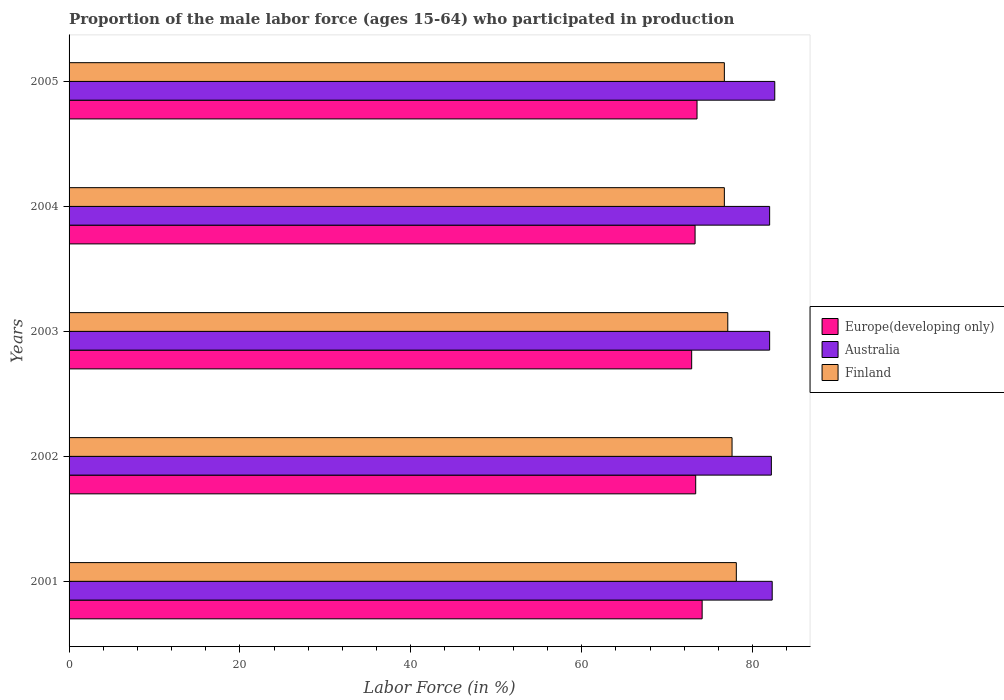How many different coloured bars are there?
Your answer should be very brief. 3. Are the number of bars on each tick of the Y-axis equal?
Provide a succinct answer. Yes. How many bars are there on the 2nd tick from the bottom?
Offer a very short reply. 3. What is the proportion of the male labor force who participated in production in Australia in 2005?
Your answer should be compact. 82.6. Across all years, what is the maximum proportion of the male labor force who participated in production in Finland?
Keep it short and to the point. 78.1. Across all years, what is the minimum proportion of the male labor force who participated in production in Finland?
Ensure brevity in your answer.  76.7. What is the total proportion of the male labor force who participated in production in Australia in the graph?
Offer a very short reply. 411.1. What is the difference between the proportion of the male labor force who participated in production in Finland in 2005 and the proportion of the male labor force who participated in production in Australia in 2001?
Ensure brevity in your answer.  -5.6. What is the average proportion of the male labor force who participated in production in Europe(developing only) per year?
Ensure brevity in your answer.  73.42. In the year 2005, what is the difference between the proportion of the male labor force who participated in production in Europe(developing only) and proportion of the male labor force who participated in production in Australia?
Your response must be concise. -9.1. What is the ratio of the proportion of the male labor force who participated in production in Europe(developing only) in 2001 to that in 2003?
Your answer should be compact. 1.02. Is the difference between the proportion of the male labor force who participated in production in Europe(developing only) in 2001 and 2003 greater than the difference between the proportion of the male labor force who participated in production in Australia in 2001 and 2003?
Make the answer very short. Yes. What is the difference between the highest and the second highest proportion of the male labor force who participated in production in Finland?
Provide a succinct answer. 0.5. What is the difference between the highest and the lowest proportion of the male labor force who participated in production in Australia?
Offer a very short reply. 0.6. What does the 3rd bar from the top in 2003 represents?
Keep it short and to the point. Europe(developing only). What does the 1st bar from the bottom in 2001 represents?
Make the answer very short. Europe(developing only). Is it the case that in every year, the sum of the proportion of the male labor force who participated in production in Europe(developing only) and proportion of the male labor force who participated in production in Finland is greater than the proportion of the male labor force who participated in production in Australia?
Ensure brevity in your answer.  Yes. How many bars are there?
Keep it short and to the point. 15. Are all the bars in the graph horizontal?
Offer a very short reply. Yes. What is the difference between two consecutive major ticks on the X-axis?
Give a very brief answer. 20. Does the graph contain any zero values?
Your answer should be very brief. No. Does the graph contain grids?
Your answer should be compact. No. Where does the legend appear in the graph?
Make the answer very short. Center right. How are the legend labels stacked?
Your answer should be very brief. Vertical. What is the title of the graph?
Your answer should be compact. Proportion of the male labor force (ages 15-64) who participated in production. What is the label or title of the X-axis?
Ensure brevity in your answer.  Labor Force (in %). What is the Labor Force (in %) in Europe(developing only) in 2001?
Provide a succinct answer. 74.1. What is the Labor Force (in %) of Australia in 2001?
Offer a terse response. 82.3. What is the Labor Force (in %) of Finland in 2001?
Your response must be concise. 78.1. What is the Labor Force (in %) of Europe(developing only) in 2002?
Provide a succinct answer. 73.34. What is the Labor Force (in %) of Australia in 2002?
Your answer should be compact. 82.2. What is the Labor Force (in %) in Finland in 2002?
Your answer should be compact. 77.6. What is the Labor Force (in %) of Europe(developing only) in 2003?
Give a very brief answer. 72.87. What is the Labor Force (in %) of Australia in 2003?
Make the answer very short. 82. What is the Labor Force (in %) of Finland in 2003?
Your answer should be very brief. 77.1. What is the Labor Force (in %) in Europe(developing only) in 2004?
Make the answer very short. 73.27. What is the Labor Force (in %) in Australia in 2004?
Your response must be concise. 82. What is the Labor Force (in %) in Finland in 2004?
Give a very brief answer. 76.7. What is the Labor Force (in %) in Europe(developing only) in 2005?
Provide a short and direct response. 73.5. What is the Labor Force (in %) in Australia in 2005?
Offer a very short reply. 82.6. What is the Labor Force (in %) of Finland in 2005?
Your answer should be very brief. 76.7. Across all years, what is the maximum Labor Force (in %) of Europe(developing only)?
Your response must be concise. 74.1. Across all years, what is the maximum Labor Force (in %) of Australia?
Give a very brief answer. 82.6. Across all years, what is the maximum Labor Force (in %) of Finland?
Offer a very short reply. 78.1. Across all years, what is the minimum Labor Force (in %) of Europe(developing only)?
Provide a succinct answer. 72.87. Across all years, what is the minimum Labor Force (in %) of Finland?
Provide a succinct answer. 76.7. What is the total Labor Force (in %) in Europe(developing only) in the graph?
Offer a terse response. 367.09. What is the total Labor Force (in %) in Australia in the graph?
Give a very brief answer. 411.1. What is the total Labor Force (in %) in Finland in the graph?
Your response must be concise. 386.2. What is the difference between the Labor Force (in %) of Europe(developing only) in 2001 and that in 2002?
Provide a short and direct response. 0.75. What is the difference between the Labor Force (in %) of Finland in 2001 and that in 2002?
Ensure brevity in your answer.  0.5. What is the difference between the Labor Force (in %) of Europe(developing only) in 2001 and that in 2003?
Provide a short and direct response. 1.23. What is the difference between the Labor Force (in %) of Finland in 2001 and that in 2003?
Offer a terse response. 1. What is the difference between the Labor Force (in %) in Europe(developing only) in 2001 and that in 2004?
Give a very brief answer. 0.83. What is the difference between the Labor Force (in %) in Finland in 2001 and that in 2004?
Ensure brevity in your answer.  1.4. What is the difference between the Labor Force (in %) of Europe(developing only) in 2001 and that in 2005?
Make the answer very short. 0.6. What is the difference between the Labor Force (in %) of Europe(developing only) in 2002 and that in 2003?
Offer a terse response. 0.47. What is the difference between the Labor Force (in %) of Finland in 2002 and that in 2003?
Your answer should be very brief. 0.5. What is the difference between the Labor Force (in %) in Europe(developing only) in 2002 and that in 2004?
Offer a very short reply. 0.07. What is the difference between the Labor Force (in %) in Australia in 2002 and that in 2004?
Ensure brevity in your answer.  0.2. What is the difference between the Labor Force (in %) in Europe(developing only) in 2002 and that in 2005?
Your response must be concise. -0.16. What is the difference between the Labor Force (in %) in Australia in 2002 and that in 2005?
Offer a very short reply. -0.4. What is the difference between the Labor Force (in %) of Europe(developing only) in 2003 and that in 2004?
Make the answer very short. -0.4. What is the difference between the Labor Force (in %) of Europe(developing only) in 2003 and that in 2005?
Ensure brevity in your answer.  -0.63. What is the difference between the Labor Force (in %) in Australia in 2003 and that in 2005?
Keep it short and to the point. -0.6. What is the difference between the Labor Force (in %) in Finland in 2003 and that in 2005?
Provide a short and direct response. 0.4. What is the difference between the Labor Force (in %) of Europe(developing only) in 2004 and that in 2005?
Give a very brief answer. -0.23. What is the difference between the Labor Force (in %) of Finland in 2004 and that in 2005?
Provide a short and direct response. 0. What is the difference between the Labor Force (in %) in Europe(developing only) in 2001 and the Labor Force (in %) in Australia in 2002?
Keep it short and to the point. -8.1. What is the difference between the Labor Force (in %) in Europe(developing only) in 2001 and the Labor Force (in %) in Finland in 2002?
Offer a very short reply. -3.5. What is the difference between the Labor Force (in %) in Europe(developing only) in 2001 and the Labor Force (in %) in Australia in 2003?
Make the answer very short. -7.9. What is the difference between the Labor Force (in %) of Europe(developing only) in 2001 and the Labor Force (in %) of Finland in 2003?
Provide a short and direct response. -3. What is the difference between the Labor Force (in %) in Europe(developing only) in 2001 and the Labor Force (in %) in Australia in 2004?
Keep it short and to the point. -7.9. What is the difference between the Labor Force (in %) in Europe(developing only) in 2001 and the Labor Force (in %) in Finland in 2004?
Make the answer very short. -2.6. What is the difference between the Labor Force (in %) in Europe(developing only) in 2001 and the Labor Force (in %) in Australia in 2005?
Make the answer very short. -8.5. What is the difference between the Labor Force (in %) in Europe(developing only) in 2001 and the Labor Force (in %) in Finland in 2005?
Your answer should be compact. -2.6. What is the difference between the Labor Force (in %) in Europe(developing only) in 2002 and the Labor Force (in %) in Australia in 2003?
Offer a terse response. -8.66. What is the difference between the Labor Force (in %) of Europe(developing only) in 2002 and the Labor Force (in %) of Finland in 2003?
Your answer should be compact. -3.76. What is the difference between the Labor Force (in %) of Europe(developing only) in 2002 and the Labor Force (in %) of Australia in 2004?
Offer a terse response. -8.66. What is the difference between the Labor Force (in %) of Europe(developing only) in 2002 and the Labor Force (in %) of Finland in 2004?
Your response must be concise. -3.36. What is the difference between the Labor Force (in %) of Australia in 2002 and the Labor Force (in %) of Finland in 2004?
Keep it short and to the point. 5.5. What is the difference between the Labor Force (in %) of Europe(developing only) in 2002 and the Labor Force (in %) of Australia in 2005?
Keep it short and to the point. -9.26. What is the difference between the Labor Force (in %) in Europe(developing only) in 2002 and the Labor Force (in %) in Finland in 2005?
Offer a terse response. -3.36. What is the difference between the Labor Force (in %) in Australia in 2002 and the Labor Force (in %) in Finland in 2005?
Offer a very short reply. 5.5. What is the difference between the Labor Force (in %) of Europe(developing only) in 2003 and the Labor Force (in %) of Australia in 2004?
Ensure brevity in your answer.  -9.13. What is the difference between the Labor Force (in %) of Europe(developing only) in 2003 and the Labor Force (in %) of Finland in 2004?
Ensure brevity in your answer.  -3.83. What is the difference between the Labor Force (in %) in Europe(developing only) in 2003 and the Labor Force (in %) in Australia in 2005?
Offer a terse response. -9.73. What is the difference between the Labor Force (in %) of Europe(developing only) in 2003 and the Labor Force (in %) of Finland in 2005?
Your response must be concise. -3.83. What is the difference between the Labor Force (in %) in Australia in 2003 and the Labor Force (in %) in Finland in 2005?
Offer a very short reply. 5.3. What is the difference between the Labor Force (in %) of Europe(developing only) in 2004 and the Labor Force (in %) of Australia in 2005?
Ensure brevity in your answer.  -9.33. What is the difference between the Labor Force (in %) in Europe(developing only) in 2004 and the Labor Force (in %) in Finland in 2005?
Provide a short and direct response. -3.43. What is the difference between the Labor Force (in %) of Australia in 2004 and the Labor Force (in %) of Finland in 2005?
Provide a succinct answer. 5.3. What is the average Labor Force (in %) of Europe(developing only) per year?
Make the answer very short. 73.42. What is the average Labor Force (in %) in Australia per year?
Ensure brevity in your answer.  82.22. What is the average Labor Force (in %) in Finland per year?
Provide a short and direct response. 77.24. In the year 2001, what is the difference between the Labor Force (in %) of Europe(developing only) and Labor Force (in %) of Australia?
Provide a succinct answer. -8.2. In the year 2001, what is the difference between the Labor Force (in %) in Europe(developing only) and Labor Force (in %) in Finland?
Offer a very short reply. -4. In the year 2002, what is the difference between the Labor Force (in %) of Europe(developing only) and Labor Force (in %) of Australia?
Provide a succinct answer. -8.86. In the year 2002, what is the difference between the Labor Force (in %) of Europe(developing only) and Labor Force (in %) of Finland?
Make the answer very short. -4.26. In the year 2002, what is the difference between the Labor Force (in %) of Australia and Labor Force (in %) of Finland?
Offer a very short reply. 4.6. In the year 2003, what is the difference between the Labor Force (in %) of Europe(developing only) and Labor Force (in %) of Australia?
Offer a very short reply. -9.13. In the year 2003, what is the difference between the Labor Force (in %) of Europe(developing only) and Labor Force (in %) of Finland?
Give a very brief answer. -4.23. In the year 2004, what is the difference between the Labor Force (in %) of Europe(developing only) and Labor Force (in %) of Australia?
Provide a short and direct response. -8.73. In the year 2004, what is the difference between the Labor Force (in %) in Europe(developing only) and Labor Force (in %) in Finland?
Keep it short and to the point. -3.43. In the year 2005, what is the difference between the Labor Force (in %) of Europe(developing only) and Labor Force (in %) of Australia?
Your answer should be compact. -9.1. In the year 2005, what is the difference between the Labor Force (in %) in Europe(developing only) and Labor Force (in %) in Finland?
Your answer should be very brief. -3.2. What is the ratio of the Labor Force (in %) of Europe(developing only) in 2001 to that in 2002?
Ensure brevity in your answer.  1.01. What is the ratio of the Labor Force (in %) of Australia in 2001 to that in 2002?
Your answer should be compact. 1. What is the ratio of the Labor Force (in %) in Finland in 2001 to that in 2002?
Offer a very short reply. 1.01. What is the ratio of the Labor Force (in %) in Europe(developing only) in 2001 to that in 2003?
Offer a terse response. 1.02. What is the ratio of the Labor Force (in %) of Australia in 2001 to that in 2003?
Offer a very short reply. 1. What is the ratio of the Labor Force (in %) in Finland in 2001 to that in 2003?
Your response must be concise. 1.01. What is the ratio of the Labor Force (in %) in Europe(developing only) in 2001 to that in 2004?
Your answer should be compact. 1.01. What is the ratio of the Labor Force (in %) in Australia in 2001 to that in 2004?
Your answer should be very brief. 1. What is the ratio of the Labor Force (in %) of Finland in 2001 to that in 2004?
Your answer should be compact. 1.02. What is the ratio of the Labor Force (in %) of Australia in 2001 to that in 2005?
Give a very brief answer. 1. What is the ratio of the Labor Force (in %) of Finland in 2001 to that in 2005?
Provide a succinct answer. 1.02. What is the ratio of the Labor Force (in %) in Europe(developing only) in 2002 to that in 2003?
Ensure brevity in your answer.  1.01. What is the ratio of the Labor Force (in %) in Australia in 2002 to that in 2003?
Your answer should be compact. 1. What is the ratio of the Labor Force (in %) of Finland in 2002 to that in 2003?
Ensure brevity in your answer.  1.01. What is the ratio of the Labor Force (in %) in Europe(developing only) in 2002 to that in 2004?
Your response must be concise. 1. What is the ratio of the Labor Force (in %) in Finland in 2002 to that in 2004?
Ensure brevity in your answer.  1.01. What is the ratio of the Labor Force (in %) of Australia in 2002 to that in 2005?
Your answer should be very brief. 1. What is the ratio of the Labor Force (in %) of Finland in 2002 to that in 2005?
Ensure brevity in your answer.  1.01. What is the ratio of the Labor Force (in %) of Europe(developing only) in 2003 to that in 2004?
Keep it short and to the point. 0.99. What is the ratio of the Labor Force (in %) of Australia in 2003 to that in 2004?
Your answer should be compact. 1. What is the ratio of the Labor Force (in %) in Australia in 2003 to that in 2005?
Ensure brevity in your answer.  0.99. What is the ratio of the Labor Force (in %) in Finland in 2003 to that in 2005?
Provide a succinct answer. 1.01. What is the ratio of the Labor Force (in %) in Europe(developing only) in 2004 to that in 2005?
Give a very brief answer. 1. What is the ratio of the Labor Force (in %) of Australia in 2004 to that in 2005?
Provide a succinct answer. 0.99. What is the difference between the highest and the second highest Labor Force (in %) of Europe(developing only)?
Your response must be concise. 0.6. What is the difference between the highest and the second highest Labor Force (in %) of Australia?
Provide a succinct answer. 0.3. What is the difference between the highest and the second highest Labor Force (in %) in Finland?
Give a very brief answer. 0.5. What is the difference between the highest and the lowest Labor Force (in %) of Europe(developing only)?
Make the answer very short. 1.23. 